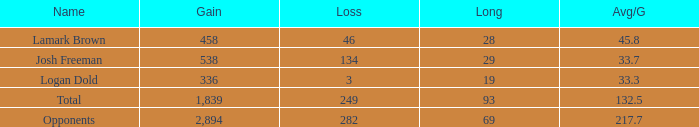Which Long is the highest one that has a Loss larger than 3, and a Gain larger than 2,894? None. 